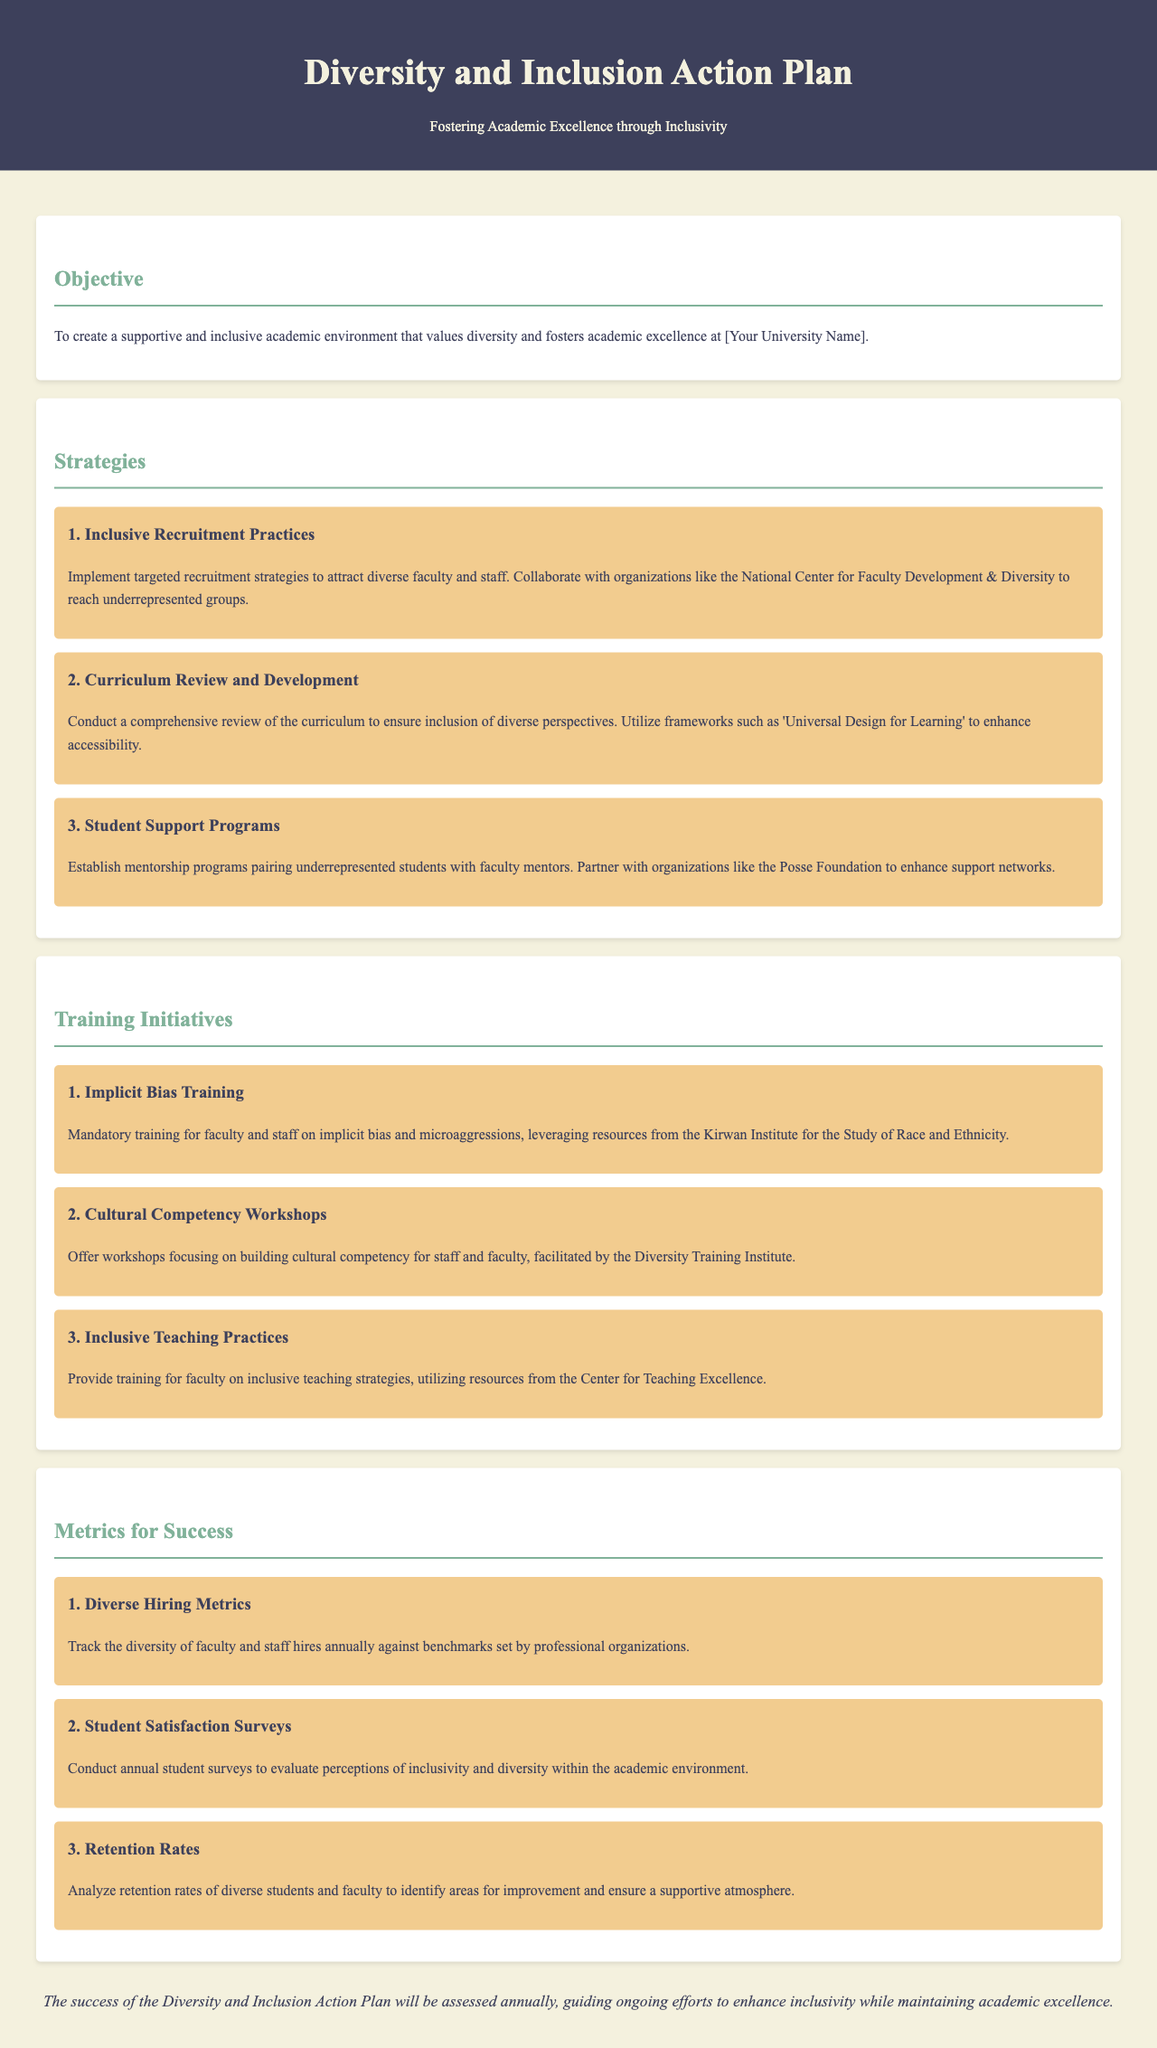what is the primary objective of the Diversity and Inclusion Action Plan? The primary objective is to create a supportive and inclusive academic environment that values diversity and fosters academic excellence.
Answer: supportive and inclusive academic environment how many strategies are listed in the document? There are three strategies mentioned under the Strategies section.
Answer: 3 what is the focus of the first training initiative? The focus of the first training initiative is on implicit bias and microaggressions.
Answer: implicit bias training which organization is mentioned in connection with the Diverse Hiring Metrics? The document references professional organizations for setting benchmarks in diverse hiring.
Answer: professional organizations what is the purpose of the student satisfaction surveys? The purpose is to evaluate perceptions of inclusivity and diversity within the academic environment.
Answer: evaluate perceptions of inclusivity and diversity how often will the Diversity and Inclusion Action Plan's success be assessed? The success of the plan will be assessed annually.
Answer: annually which framework is mentioned for enhancing accessibility in curriculum review? The framework mentioned is 'Universal Design for Learning'.
Answer: Universal Design for Learning what is the key outcome for retention rates? The key outcome is to identify areas for improvement and ensure a supportive atmosphere.
Answer: identify areas for improvement 